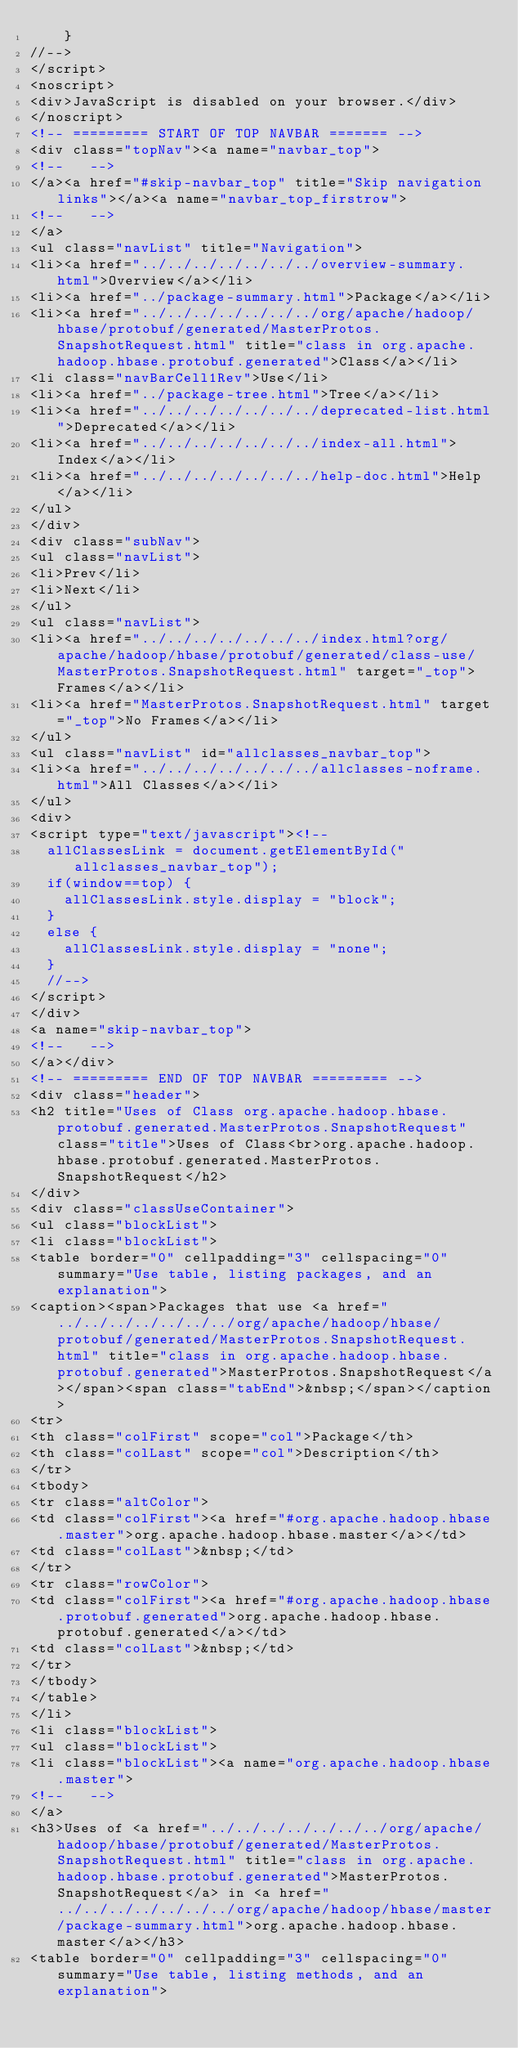Convert code to text. <code><loc_0><loc_0><loc_500><loc_500><_HTML_>    }
//-->
</script>
<noscript>
<div>JavaScript is disabled on your browser.</div>
</noscript>
<!-- ========= START OF TOP NAVBAR ======= -->
<div class="topNav"><a name="navbar_top">
<!--   -->
</a><a href="#skip-navbar_top" title="Skip navigation links"></a><a name="navbar_top_firstrow">
<!--   -->
</a>
<ul class="navList" title="Navigation">
<li><a href="../../../../../../../overview-summary.html">Overview</a></li>
<li><a href="../package-summary.html">Package</a></li>
<li><a href="../../../../../../../org/apache/hadoop/hbase/protobuf/generated/MasterProtos.SnapshotRequest.html" title="class in org.apache.hadoop.hbase.protobuf.generated">Class</a></li>
<li class="navBarCell1Rev">Use</li>
<li><a href="../package-tree.html">Tree</a></li>
<li><a href="../../../../../../../deprecated-list.html">Deprecated</a></li>
<li><a href="../../../../../../../index-all.html">Index</a></li>
<li><a href="../../../../../../../help-doc.html">Help</a></li>
</ul>
</div>
<div class="subNav">
<ul class="navList">
<li>Prev</li>
<li>Next</li>
</ul>
<ul class="navList">
<li><a href="../../../../../../../index.html?org/apache/hadoop/hbase/protobuf/generated/class-use/MasterProtos.SnapshotRequest.html" target="_top">Frames</a></li>
<li><a href="MasterProtos.SnapshotRequest.html" target="_top">No Frames</a></li>
</ul>
<ul class="navList" id="allclasses_navbar_top">
<li><a href="../../../../../../../allclasses-noframe.html">All Classes</a></li>
</ul>
<div>
<script type="text/javascript"><!--
  allClassesLink = document.getElementById("allclasses_navbar_top");
  if(window==top) {
    allClassesLink.style.display = "block";
  }
  else {
    allClassesLink.style.display = "none";
  }
  //-->
</script>
</div>
<a name="skip-navbar_top">
<!--   -->
</a></div>
<!-- ========= END OF TOP NAVBAR ========= -->
<div class="header">
<h2 title="Uses of Class org.apache.hadoop.hbase.protobuf.generated.MasterProtos.SnapshotRequest" class="title">Uses of Class<br>org.apache.hadoop.hbase.protobuf.generated.MasterProtos.SnapshotRequest</h2>
</div>
<div class="classUseContainer">
<ul class="blockList">
<li class="blockList">
<table border="0" cellpadding="3" cellspacing="0" summary="Use table, listing packages, and an explanation">
<caption><span>Packages that use <a href="../../../../../../../org/apache/hadoop/hbase/protobuf/generated/MasterProtos.SnapshotRequest.html" title="class in org.apache.hadoop.hbase.protobuf.generated">MasterProtos.SnapshotRequest</a></span><span class="tabEnd">&nbsp;</span></caption>
<tr>
<th class="colFirst" scope="col">Package</th>
<th class="colLast" scope="col">Description</th>
</tr>
<tbody>
<tr class="altColor">
<td class="colFirst"><a href="#org.apache.hadoop.hbase.master">org.apache.hadoop.hbase.master</a></td>
<td class="colLast">&nbsp;</td>
</tr>
<tr class="rowColor">
<td class="colFirst"><a href="#org.apache.hadoop.hbase.protobuf.generated">org.apache.hadoop.hbase.protobuf.generated</a></td>
<td class="colLast">&nbsp;</td>
</tr>
</tbody>
</table>
</li>
<li class="blockList">
<ul class="blockList">
<li class="blockList"><a name="org.apache.hadoop.hbase.master">
<!--   -->
</a>
<h3>Uses of <a href="../../../../../../../org/apache/hadoop/hbase/protobuf/generated/MasterProtos.SnapshotRequest.html" title="class in org.apache.hadoop.hbase.protobuf.generated">MasterProtos.SnapshotRequest</a> in <a href="../../../../../../../org/apache/hadoop/hbase/master/package-summary.html">org.apache.hadoop.hbase.master</a></h3>
<table border="0" cellpadding="3" cellspacing="0" summary="Use table, listing methods, and an explanation"></code> 